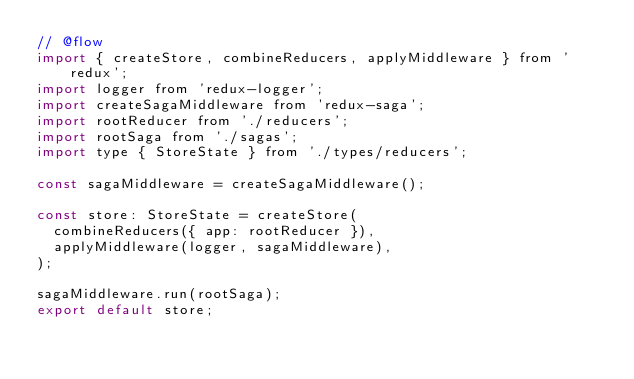<code> <loc_0><loc_0><loc_500><loc_500><_JavaScript_>// @flow
import { createStore, combineReducers, applyMiddleware } from 'redux';
import logger from 'redux-logger';
import createSagaMiddleware from 'redux-saga';
import rootReducer from './reducers';
import rootSaga from './sagas';
import type { StoreState } from './types/reducers';

const sagaMiddleware = createSagaMiddleware();

const store: StoreState = createStore(
  combineReducers({ app: rootReducer }),
  applyMiddleware(logger, sagaMiddleware),
);

sagaMiddleware.run(rootSaga);
export default store;
</code> 